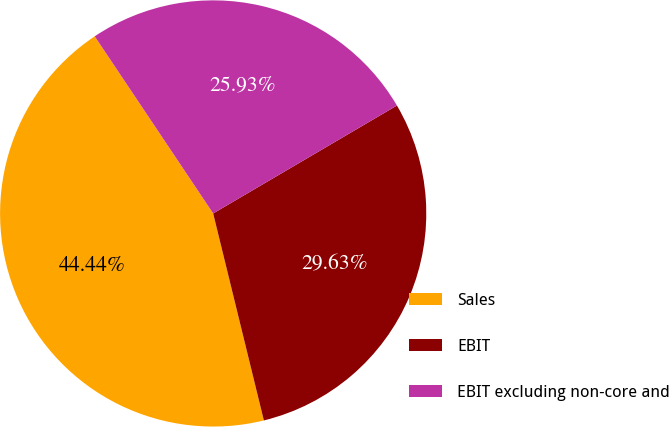Convert chart to OTSL. <chart><loc_0><loc_0><loc_500><loc_500><pie_chart><fcel>Sales<fcel>EBIT<fcel>EBIT excluding non-core and<nl><fcel>44.44%<fcel>29.63%<fcel>25.93%<nl></chart> 